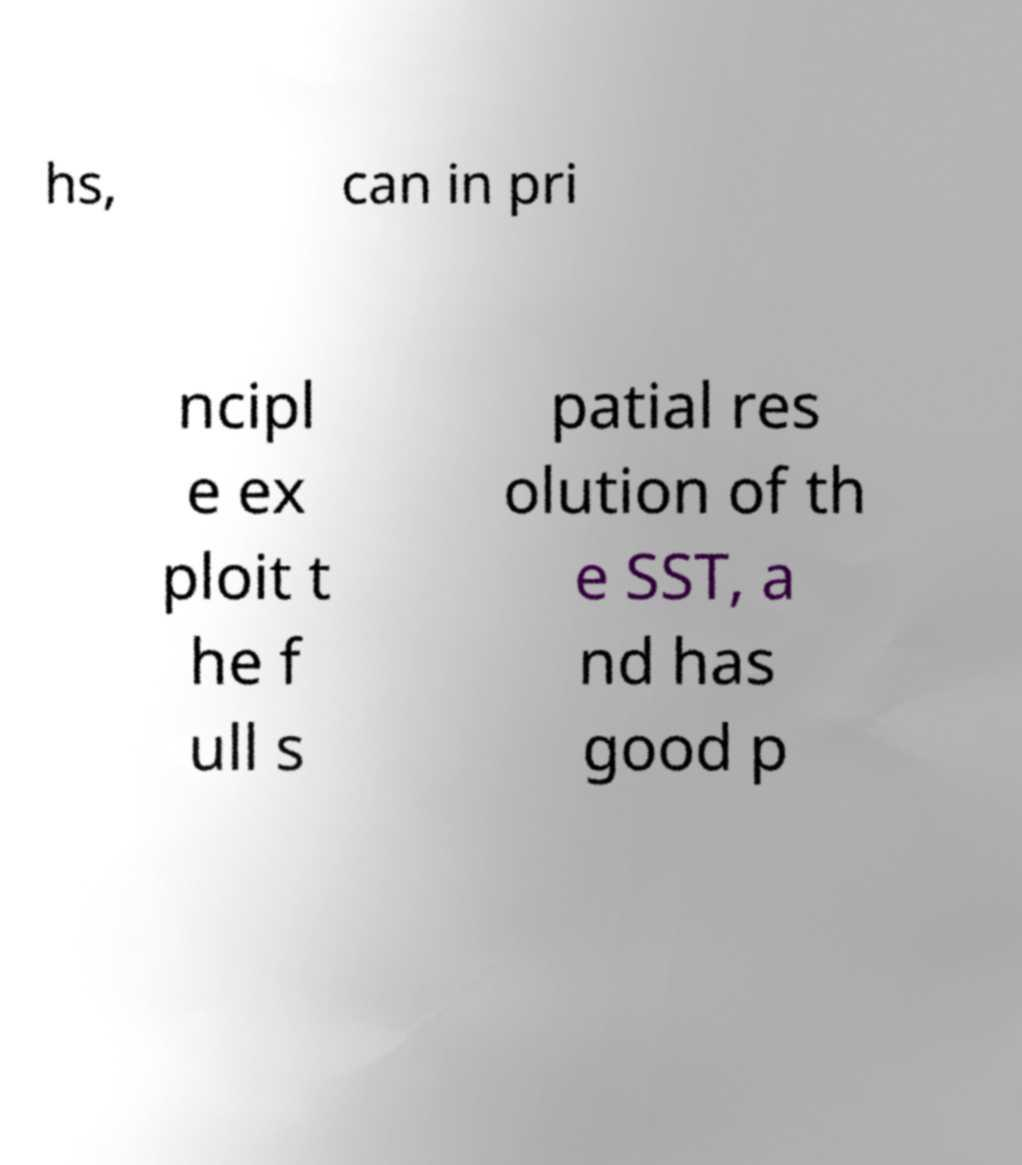I need the written content from this picture converted into text. Can you do that? hs, can in pri ncipl e ex ploit t he f ull s patial res olution of th e SST, a nd has good p 